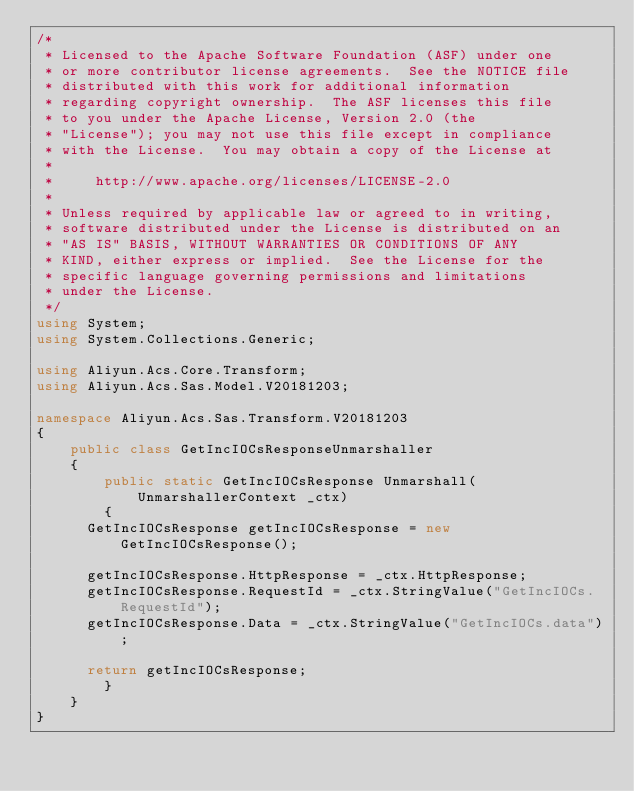<code> <loc_0><loc_0><loc_500><loc_500><_C#_>/*
 * Licensed to the Apache Software Foundation (ASF) under one
 * or more contributor license agreements.  See the NOTICE file
 * distributed with this work for additional information
 * regarding copyright ownership.  The ASF licenses this file
 * to you under the Apache License, Version 2.0 (the
 * "License"); you may not use this file except in compliance
 * with the License.  You may obtain a copy of the License at
 *
 *     http://www.apache.org/licenses/LICENSE-2.0
 *
 * Unless required by applicable law or agreed to in writing,
 * software distributed under the License is distributed on an
 * "AS IS" BASIS, WITHOUT WARRANTIES OR CONDITIONS OF ANY
 * KIND, either express or implied.  See the License for the
 * specific language governing permissions and limitations
 * under the License.
 */
using System;
using System.Collections.Generic;

using Aliyun.Acs.Core.Transform;
using Aliyun.Acs.Sas.Model.V20181203;

namespace Aliyun.Acs.Sas.Transform.V20181203
{
    public class GetIncIOCsResponseUnmarshaller
    {
        public static GetIncIOCsResponse Unmarshall(UnmarshallerContext _ctx)
        {
			GetIncIOCsResponse getIncIOCsResponse = new GetIncIOCsResponse();

			getIncIOCsResponse.HttpResponse = _ctx.HttpResponse;
			getIncIOCsResponse.RequestId = _ctx.StringValue("GetIncIOCs.RequestId");
			getIncIOCsResponse.Data = _ctx.StringValue("GetIncIOCs.data");
        
			return getIncIOCsResponse;
        }
    }
}
</code> 